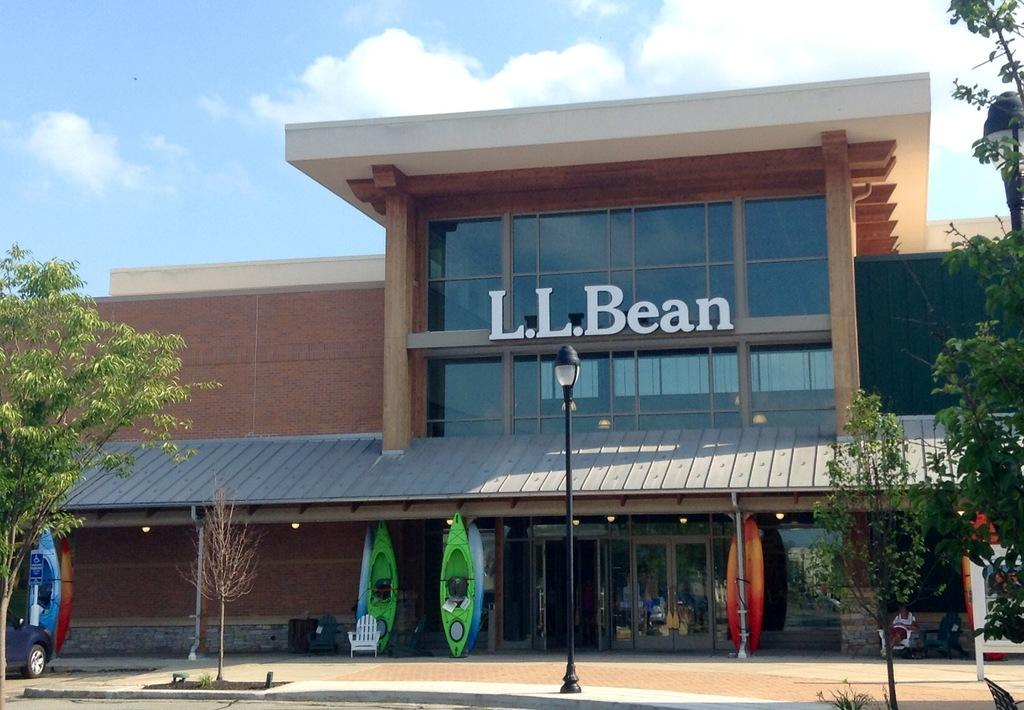What type of structure is present in the image? There is a building in the image. What can be seen on the building? The building has some text on it. What other smaller structure is visible in the image? There is a shed in the image. Can you identify any entrance in the image? There is a door in the image. What type of outdoor lighting is present in the image? There is a light pole in the image. What type of natural elements are present in the image? There are trees in the image. What type of transportation is visible in the image? There is a vehicle in the image. What type of furniture is present in the image? There is a chair in the image. What is visible in the background of the image? The sky is visible in the image. What type of magic is being performed in the image? There is no magic being performed in the image; it is a scene of a building, shed, door, light pole, trees, vehicle, chair, and sky. 